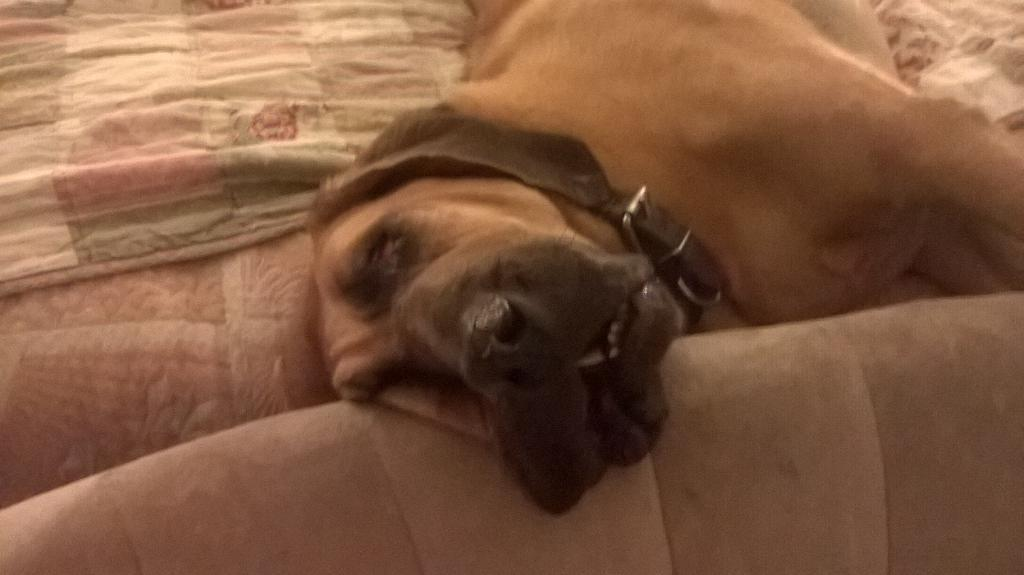What is the main subject in the center of the image? There is a dog in the center of the image. What else can be seen in the image besides the dog? There is a bed in the image. What is covering the bed? The bed has a blanket on it. What language is the dog speaking in the image? Dogs do not speak human languages, so there is no language spoken by the dog in the image. 